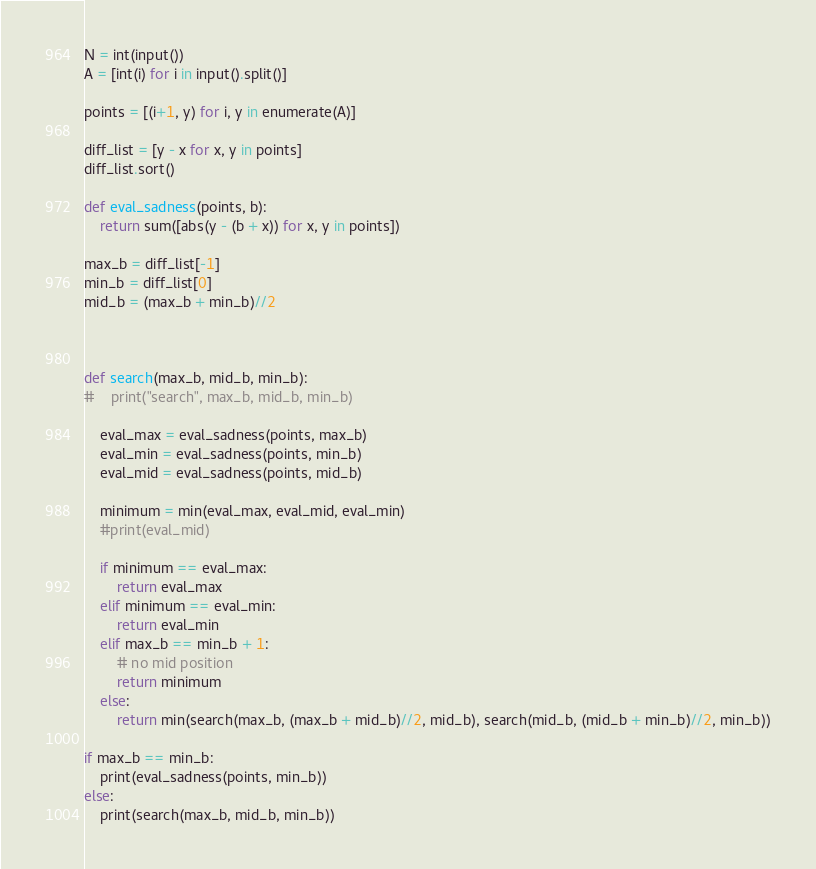<code> <loc_0><loc_0><loc_500><loc_500><_Python_>N = int(input())
A = [int(i) for i in input().split()]

points = [(i+1, y) for i, y in enumerate(A)]

diff_list = [y - x for x, y in points]
diff_list.sort()

def eval_sadness(points, b):
    return sum([abs(y - (b + x)) for x, y in points])

max_b = diff_list[-1]
min_b = diff_list[0]
mid_b = (max_b + min_b)//2



def search(max_b, mid_b, min_b):
#    print("search", max_b, mid_b, min_b)
    
    eval_max = eval_sadness(points, max_b)
    eval_min = eval_sadness(points, min_b)
    eval_mid = eval_sadness(points, mid_b)

    minimum = min(eval_max, eval_mid, eval_min)
    #print(eval_mid)

    if minimum == eval_max:
        return eval_max
    elif minimum == eval_min:
        return eval_min
    elif max_b == min_b + 1:
        # no mid position
        return minimum
    else:
        return min(search(max_b, (max_b + mid_b)//2, mid_b), search(mid_b, (mid_b + min_b)//2, min_b))

if max_b == min_b:
    print(eval_sadness(points, min_b))
else:
    print(search(max_b, mid_b, min_b))</code> 